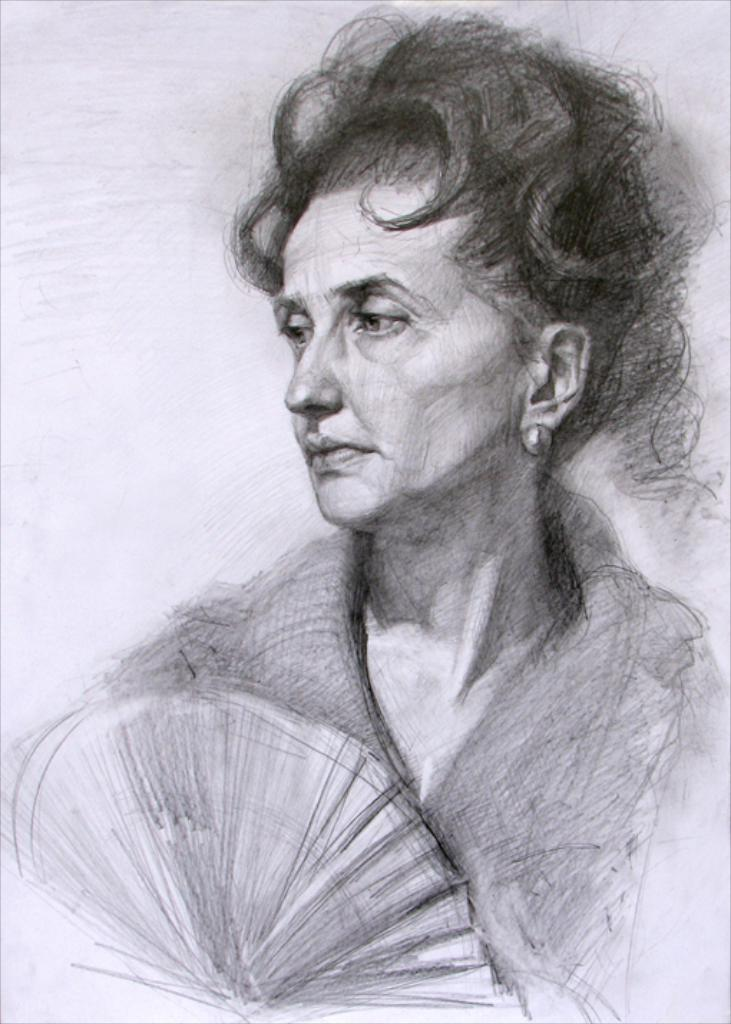What type of art is featured in the image? The image contains pencil art. What subject is depicted in the pencil art? The pencil art depicts a woman. What object is the woman holding in the art? The woman is holding a Japanese fan in the art. What type of cheese is being served by the company in the image? There is no cheese or company present in the image; it features pencil art of a woman holding a Japanese fan. 